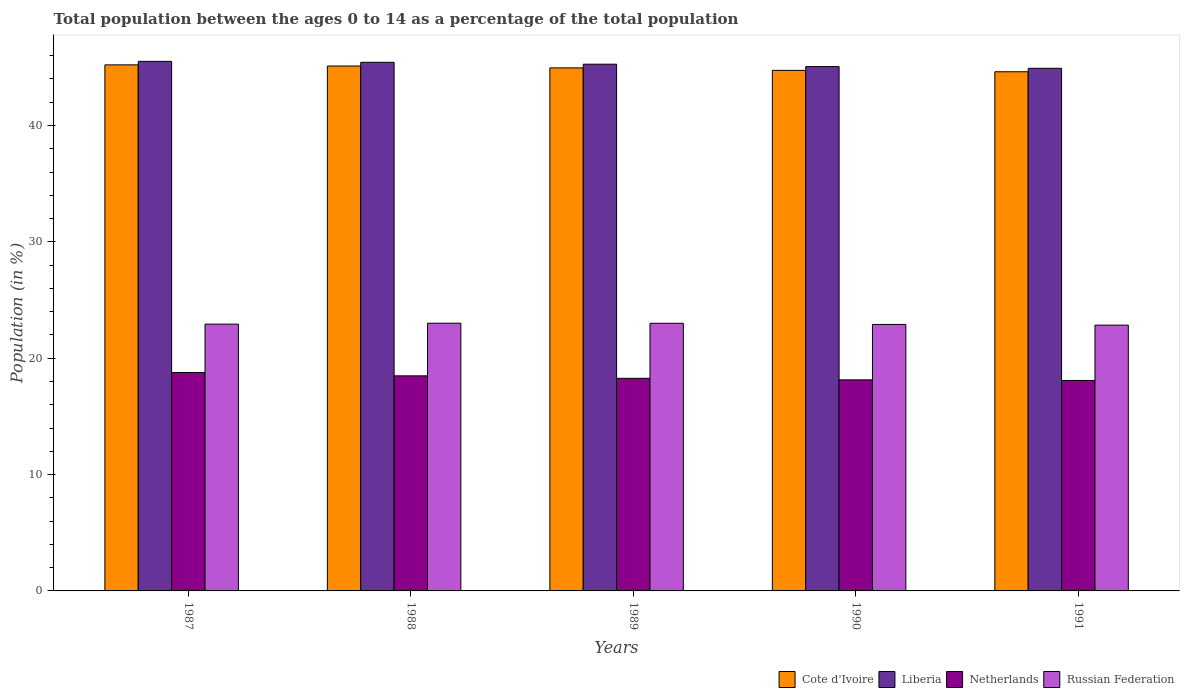How many different coloured bars are there?
Offer a terse response. 4. How many groups of bars are there?
Provide a short and direct response. 5. Are the number of bars per tick equal to the number of legend labels?
Your answer should be very brief. Yes. In how many cases, is the number of bars for a given year not equal to the number of legend labels?
Make the answer very short. 0. What is the percentage of the population ages 0 to 14 in Netherlands in 1988?
Offer a terse response. 18.48. Across all years, what is the maximum percentage of the population ages 0 to 14 in Netherlands?
Keep it short and to the point. 18.77. Across all years, what is the minimum percentage of the population ages 0 to 14 in Liberia?
Your answer should be compact. 44.92. What is the total percentage of the population ages 0 to 14 in Russian Federation in the graph?
Your response must be concise. 114.68. What is the difference between the percentage of the population ages 0 to 14 in Liberia in 1989 and that in 1990?
Ensure brevity in your answer.  0.21. What is the difference between the percentage of the population ages 0 to 14 in Russian Federation in 1991 and the percentage of the population ages 0 to 14 in Netherlands in 1990?
Your answer should be compact. 4.7. What is the average percentage of the population ages 0 to 14 in Liberia per year?
Keep it short and to the point. 45.24. In the year 1988, what is the difference between the percentage of the population ages 0 to 14 in Netherlands and percentage of the population ages 0 to 14 in Liberia?
Ensure brevity in your answer.  -26.95. What is the ratio of the percentage of the population ages 0 to 14 in Liberia in 1989 to that in 1991?
Provide a short and direct response. 1.01. Is the percentage of the population ages 0 to 14 in Netherlands in 1987 less than that in 1989?
Your answer should be compact. No. What is the difference between the highest and the second highest percentage of the population ages 0 to 14 in Cote d'Ivoire?
Your answer should be compact. 0.1. What is the difference between the highest and the lowest percentage of the population ages 0 to 14 in Russian Federation?
Keep it short and to the point. 0.17. In how many years, is the percentage of the population ages 0 to 14 in Cote d'Ivoire greater than the average percentage of the population ages 0 to 14 in Cote d'Ivoire taken over all years?
Your answer should be very brief. 3. What does the 2nd bar from the left in 1991 represents?
Ensure brevity in your answer.  Liberia. What does the 2nd bar from the right in 1991 represents?
Give a very brief answer. Netherlands. How many bars are there?
Your response must be concise. 20. How many years are there in the graph?
Provide a short and direct response. 5. Are the values on the major ticks of Y-axis written in scientific E-notation?
Keep it short and to the point. No. Does the graph contain grids?
Offer a terse response. No. Where does the legend appear in the graph?
Your response must be concise. Bottom right. How many legend labels are there?
Ensure brevity in your answer.  4. What is the title of the graph?
Keep it short and to the point. Total population between the ages 0 to 14 as a percentage of the total population. What is the label or title of the X-axis?
Make the answer very short. Years. What is the label or title of the Y-axis?
Your response must be concise. Population (in %). What is the Population (in %) of Cote d'Ivoire in 1987?
Ensure brevity in your answer.  45.21. What is the Population (in %) in Liberia in 1987?
Your answer should be very brief. 45.51. What is the Population (in %) of Netherlands in 1987?
Provide a short and direct response. 18.77. What is the Population (in %) in Russian Federation in 1987?
Keep it short and to the point. 22.93. What is the Population (in %) in Cote d'Ivoire in 1988?
Your response must be concise. 45.11. What is the Population (in %) of Liberia in 1988?
Ensure brevity in your answer.  45.43. What is the Population (in %) in Netherlands in 1988?
Your answer should be compact. 18.48. What is the Population (in %) in Russian Federation in 1988?
Offer a terse response. 23.01. What is the Population (in %) of Cote d'Ivoire in 1989?
Your answer should be compact. 44.95. What is the Population (in %) of Liberia in 1989?
Your answer should be compact. 45.27. What is the Population (in %) in Netherlands in 1989?
Provide a succinct answer. 18.27. What is the Population (in %) of Russian Federation in 1989?
Keep it short and to the point. 23. What is the Population (in %) in Cote d'Ivoire in 1990?
Keep it short and to the point. 44.74. What is the Population (in %) in Liberia in 1990?
Give a very brief answer. 45.06. What is the Population (in %) of Netherlands in 1990?
Your answer should be compact. 18.14. What is the Population (in %) in Russian Federation in 1990?
Provide a succinct answer. 22.9. What is the Population (in %) of Cote d'Ivoire in 1991?
Your answer should be compact. 44.62. What is the Population (in %) in Liberia in 1991?
Your answer should be very brief. 44.92. What is the Population (in %) in Netherlands in 1991?
Your answer should be very brief. 18.09. What is the Population (in %) of Russian Federation in 1991?
Provide a short and direct response. 22.84. Across all years, what is the maximum Population (in %) in Cote d'Ivoire?
Provide a short and direct response. 45.21. Across all years, what is the maximum Population (in %) in Liberia?
Provide a succinct answer. 45.51. Across all years, what is the maximum Population (in %) in Netherlands?
Your answer should be compact. 18.77. Across all years, what is the maximum Population (in %) of Russian Federation?
Your answer should be compact. 23.01. Across all years, what is the minimum Population (in %) in Cote d'Ivoire?
Keep it short and to the point. 44.62. Across all years, what is the minimum Population (in %) of Liberia?
Your answer should be compact. 44.92. Across all years, what is the minimum Population (in %) of Netherlands?
Your answer should be compact. 18.09. Across all years, what is the minimum Population (in %) of Russian Federation?
Provide a short and direct response. 22.84. What is the total Population (in %) of Cote d'Ivoire in the graph?
Keep it short and to the point. 224.62. What is the total Population (in %) of Liberia in the graph?
Ensure brevity in your answer.  226.18. What is the total Population (in %) of Netherlands in the graph?
Provide a short and direct response. 91.75. What is the total Population (in %) in Russian Federation in the graph?
Your answer should be compact. 114.68. What is the difference between the Population (in %) of Cote d'Ivoire in 1987 and that in 1988?
Provide a short and direct response. 0.1. What is the difference between the Population (in %) in Liberia in 1987 and that in 1988?
Provide a short and direct response. 0.08. What is the difference between the Population (in %) in Netherlands in 1987 and that in 1988?
Make the answer very short. 0.28. What is the difference between the Population (in %) in Russian Federation in 1987 and that in 1988?
Provide a short and direct response. -0.08. What is the difference between the Population (in %) of Cote d'Ivoire in 1987 and that in 1989?
Your answer should be very brief. 0.26. What is the difference between the Population (in %) of Liberia in 1987 and that in 1989?
Provide a succinct answer. 0.24. What is the difference between the Population (in %) in Netherlands in 1987 and that in 1989?
Offer a terse response. 0.5. What is the difference between the Population (in %) in Russian Federation in 1987 and that in 1989?
Your answer should be very brief. -0.07. What is the difference between the Population (in %) of Cote d'Ivoire in 1987 and that in 1990?
Make the answer very short. 0.47. What is the difference between the Population (in %) of Liberia in 1987 and that in 1990?
Your response must be concise. 0.45. What is the difference between the Population (in %) in Netherlands in 1987 and that in 1990?
Provide a short and direct response. 0.63. What is the difference between the Population (in %) of Russian Federation in 1987 and that in 1990?
Give a very brief answer. 0.03. What is the difference between the Population (in %) of Cote d'Ivoire in 1987 and that in 1991?
Provide a succinct answer. 0.59. What is the difference between the Population (in %) of Liberia in 1987 and that in 1991?
Give a very brief answer. 0.6. What is the difference between the Population (in %) of Netherlands in 1987 and that in 1991?
Offer a very short reply. 0.68. What is the difference between the Population (in %) of Russian Federation in 1987 and that in 1991?
Your answer should be very brief. 0.09. What is the difference between the Population (in %) in Cote d'Ivoire in 1988 and that in 1989?
Your response must be concise. 0.16. What is the difference between the Population (in %) of Liberia in 1988 and that in 1989?
Your response must be concise. 0.16. What is the difference between the Population (in %) in Netherlands in 1988 and that in 1989?
Provide a short and direct response. 0.21. What is the difference between the Population (in %) in Russian Federation in 1988 and that in 1989?
Ensure brevity in your answer.  0.01. What is the difference between the Population (in %) of Liberia in 1988 and that in 1990?
Offer a very short reply. 0.37. What is the difference between the Population (in %) of Netherlands in 1988 and that in 1990?
Your answer should be very brief. 0.34. What is the difference between the Population (in %) of Russian Federation in 1988 and that in 1990?
Offer a terse response. 0.1. What is the difference between the Population (in %) in Cote d'Ivoire in 1988 and that in 1991?
Give a very brief answer. 0.49. What is the difference between the Population (in %) in Liberia in 1988 and that in 1991?
Offer a terse response. 0.51. What is the difference between the Population (in %) in Netherlands in 1988 and that in 1991?
Ensure brevity in your answer.  0.39. What is the difference between the Population (in %) in Russian Federation in 1988 and that in 1991?
Your answer should be compact. 0.17. What is the difference between the Population (in %) in Cote d'Ivoire in 1989 and that in 1990?
Your answer should be very brief. 0.22. What is the difference between the Population (in %) of Liberia in 1989 and that in 1990?
Make the answer very short. 0.21. What is the difference between the Population (in %) of Netherlands in 1989 and that in 1990?
Provide a succinct answer. 0.13. What is the difference between the Population (in %) of Russian Federation in 1989 and that in 1990?
Make the answer very short. 0.1. What is the difference between the Population (in %) in Liberia in 1989 and that in 1991?
Offer a very short reply. 0.35. What is the difference between the Population (in %) in Netherlands in 1989 and that in 1991?
Give a very brief answer. 0.18. What is the difference between the Population (in %) of Russian Federation in 1989 and that in 1991?
Offer a terse response. 0.16. What is the difference between the Population (in %) of Cote d'Ivoire in 1990 and that in 1991?
Offer a very short reply. 0.12. What is the difference between the Population (in %) of Liberia in 1990 and that in 1991?
Make the answer very short. 0.15. What is the difference between the Population (in %) of Netherlands in 1990 and that in 1991?
Your answer should be very brief. 0.05. What is the difference between the Population (in %) in Russian Federation in 1990 and that in 1991?
Offer a very short reply. 0.06. What is the difference between the Population (in %) in Cote d'Ivoire in 1987 and the Population (in %) in Liberia in 1988?
Make the answer very short. -0.22. What is the difference between the Population (in %) of Cote d'Ivoire in 1987 and the Population (in %) of Netherlands in 1988?
Your response must be concise. 26.73. What is the difference between the Population (in %) in Cote d'Ivoire in 1987 and the Population (in %) in Russian Federation in 1988?
Offer a terse response. 22.2. What is the difference between the Population (in %) in Liberia in 1987 and the Population (in %) in Netherlands in 1988?
Your response must be concise. 27.03. What is the difference between the Population (in %) of Liberia in 1987 and the Population (in %) of Russian Federation in 1988?
Offer a terse response. 22.5. What is the difference between the Population (in %) of Netherlands in 1987 and the Population (in %) of Russian Federation in 1988?
Your answer should be very brief. -4.24. What is the difference between the Population (in %) of Cote d'Ivoire in 1987 and the Population (in %) of Liberia in 1989?
Your response must be concise. -0.06. What is the difference between the Population (in %) in Cote d'Ivoire in 1987 and the Population (in %) in Netherlands in 1989?
Give a very brief answer. 26.94. What is the difference between the Population (in %) in Cote d'Ivoire in 1987 and the Population (in %) in Russian Federation in 1989?
Offer a terse response. 22.21. What is the difference between the Population (in %) in Liberia in 1987 and the Population (in %) in Netherlands in 1989?
Offer a terse response. 27.24. What is the difference between the Population (in %) of Liberia in 1987 and the Population (in %) of Russian Federation in 1989?
Give a very brief answer. 22.51. What is the difference between the Population (in %) in Netherlands in 1987 and the Population (in %) in Russian Federation in 1989?
Your response must be concise. -4.23. What is the difference between the Population (in %) in Cote d'Ivoire in 1987 and the Population (in %) in Liberia in 1990?
Provide a short and direct response. 0.15. What is the difference between the Population (in %) of Cote d'Ivoire in 1987 and the Population (in %) of Netherlands in 1990?
Provide a short and direct response. 27.07. What is the difference between the Population (in %) of Cote d'Ivoire in 1987 and the Population (in %) of Russian Federation in 1990?
Provide a short and direct response. 22.31. What is the difference between the Population (in %) in Liberia in 1987 and the Population (in %) in Netherlands in 1990?
Offer a terse response. 27.37. What is the difference between the Population (in %) of Liberia in 1987 and the Population (in %) of Russian Federation in 1990?
Ensure brevity in your answer.  22.61. What is the difference between the Population (in %) in Netherlands in 1987 and the Population (in %) in Russian Federation in 1990?
Give a very brief answer. -4.14. What is the difference between the Population (in %) in Cote d'Ivoire in 1987 and the Population (in %) in Liberia in 1991?
Your answer should be very brief. 0.29. What is the difference between the Population (in %) of Cote d'Ivoire in 1987 and the Population (in %) of Netherlands in 1991?
Your answer should be very brief. 27.12. What is the difference between the Population (in %) of Cote d'Ivoire in 1987 and the Population (in %) of Russian Federation in 1991?
Your answer should be compact. 22.37. What is the difference between the Population (in %) of Liberia in 1987 and the Population (in %) of Netherlands in 1991?
Give a very brief answer. 27.42. What is the difference between the Population (in %) in Liberia in 1987 and the Population (in %) in Russian Federation in 1991?
Provide a succinct answer. 22.67. What is the difference between the Population (in %) in Netherlands in 1987 and the Population (in %) in Russian Federation in 1991?
Give a very brief answer. -4.07. What is the difference between the Population (in %) in Cote d'Ivoire in 1988 and the Population (in %) in Liberia in 1989?
Keep it short and to the point. -0.16. What is the difference between the Population (in %) in Cote d'Ivoire in 1988 and the Population (in %) in Netherlands in 1989?
Offer a terse response. 26.84. What is the difference between the Population (in %) in Cote d'Ivoire in 1988 and the Population (in %) in Russian Federation in 1989?
Provide a short and direct response. 22.11. What is the difference between the Population (in %) of Liberia in 1988 and the Population (in %) of Netherlands in 1989?
Give a very brief answer. 27.16. What is the difference between the Population (in %) in Liberia in 1988 and the Population (in %) in Russian Federation in 1989?
Offer a very short reply. 22.43. What is the difference between the Population (in %) of Netherlands in 1988 and the Population (in %) of Russian Federation in 1989?
Offer a very short reply. -4.52. What is the difference between the Population (in %) in Cote d'Ivoire in 1988 and the Population (in %) in Liberia in 1990?
Keep it short and to the point. 0.05. What is the difference between the Population (in %) of Cote d'Ivoire in 1988 and the Population (in %) of Netherlands in 1990?
Your answer should be very brief. 26.97. What is the difference between the Population (in %) in Cote d'Ivoire in 1988 and the Population (in %) in Russian Federation in 1990?
Offer a terse response. 22.21. What is the difference between the Population (in %) of Liberia in 1988 and the Population (in %) of Netherlands in 1990?
Ensure brevity in your answer.  27.29. What is the difference between the Population (in %) of Liberia in 1988 and the Population (in %) of Russian Federation in 1990?
Offer a terse response. 22.53. What is the difference between the Population (in %) of Netherlands in 1988 and the Population (in %) of Russian Federation in 1990?
Make the answer very short. -4.42. What is the difference between the Population (in %) in Cote d'Ivoire in 1988 and the Population (in %) in Liberia in 1991?
Your answer should be compact. 0.2. What is the difference between the Population (in %) in Cote d'Ivoire in 1988 and the Population (in %) in Netherlands in 1991?
Keep it short and to the point. 27.02. What is the difference between the Population (in %) of Cote d'Ivoire in 1988 and the Population (in %) of Russian Federation in 1991?
Your answer should be very brief. 22.27. What is the difference between the Population (in %) of Liberia in 1988 and the Population (in %) of Netherlands in 1991?
Ensure brevity in your answer.  27.34. What is the difference between the Population (in %) of Liberia in 1988 and the Population (in %) of Russian Federation in 1991?
Your answer should be very brief. 22.59. What is the difference between the Population (in %) in Netherlands in 1988 and the Population (in %) in Russian Federation in 1991?
Your answer should be very brief. -4.36. What is the difference between the Population (in %) in Cote d'Ivoire in 1989 and the Population (in %) in Liberia in 1990?
Your response must be concise. -0.11. What is the difference between the Population (in %) in Cote d'Ivoire in 1989 and the Population (in %) in Netherlands in 1990?
Provide a short and direct response. 26.81. What is the difference between the Population (in %) in Cote d'Ivoire in 1989 and the Population (in %) in Russian Federation in 1990?
Your answer should be compact. 22.05. What is the difference between the Population (in %) in Liberia in 1989 and the Population (in %) in Netherlands in 1990?
Keep it short and to the point. 27.13. What is the difference between the Population (in %) of Liberia in 1989 and the Population (in %) of Russian Federation in 1990?
Offer a terse response. 22.36. What is the difference between the Population (in %) of Netherlands in 1989 and the Population (in %) of Russian Federation in 1990?
Give a very brief answer. -4.63. What is the difference between the Population (in %) in Cote d'Ivoire in 1989 and the Population (in %) in Liberia in 1991?
Provide a short and direct response. 0.04. What is the difference between the Population (in %) in Cote d'Ivoire in 1989 and the Population (in %) in Netherlands in 1991?
Your answer should be very brief. 26.86. What is the difference between the Population (in %) of Cote d'Ivoire in 1989 and the Population (in %) of Russian Federation in 1991?
Provide a succinct answer. 22.11. What is the difference between the Population (in %) in Liberia in 1989 and the Population (in %) in Netherlands in 1991?
Offer a terse response. 27.18. What is the difference between the Population (in %) in Liberia in 1989 and the Population (in %) in Russian Federation in 1991?
Your answer should be compact. 22.42. What is the difference between the Population (in %) in Netherlands in 1989 and the Population (in %) in Russian Federation in 1991?
Your response must be concise. -4.57. What is the difference between the Population (in %) of Cote d'Ivoire in 1990 and the Population (in %) of Liberia in 1991?
Your answer should be compact. -0.18. What is the difference between the Population (in %) in Cote d'Ivoire in 1990 and the Population (in %) in Netherlands in 1991?
Provide a short and direct response. 26.65. What is the difference between the Population (in %) in Cote d'Ivoire in 1990 and the Population (in %) in Russian Federation in 1991?
Give a very brief answer. 21.89. What is the difference between the Population (in %) in Liberia in 1990 and the Population (in %) in Netherlands in 1991?
Keep it short and to the point. 26.97. What is the difference between the Population (in %) of Liberia in 1990 and the Population (in %) of Russian Federation in 1991?
Your answer should be very brief. 22.22. What is the difference between the Population (in %) in Netherlands in 1990 and the Population (in %) in Russian Federation in 1991?
Offer a terse response. -4.7. What is the average Population (in %) of Cote d'Ivoire per year?
Make the answer very short. 44.92. What is the average Population (in %) of Liberia per year?
Make the answer very short. 45.24. What is the average Population (in %) of Netherlands per year?
Your answer should be compact. 18.35. What is the average Population (in %) of Russian Federation per year?
Keep it short and to the point. 22.94. In the year 1987, what is the difference between the Population (in %) in Cote d'Ivoire and Population (in %) in Liberia?
Make the answer very short. -0.3. In the year 1987, what is the difference between the Population (in %) of Cote d'Ivoire and Population (in %) of Netherlands?
Your response must be concise. 26.44. In the year 1987, what is the difference between the Population (in %) in Cote d'Ivoire and Population (in %) in Russian Federation?
Your answer should be very brief. 22.28. In the year 1987, what is the difference between the Population (in %) in Liberia and Population (in %) in Netherlands?
Your answer should be compact. 26.74. In the year 1987, what is the difference between the Population (in %) of Liberia and Population (in %) of Russian Federation?
Your answer should be compact. 22.58. In the year 1987, what is the difference between the Population (in %) in Netherlands and Population (in %) in Russian Federation?
Your answer should be very brief. -4.16. In the year 1988, what is the difference between the Population (in %) of Cote d'Ivoire and Population (in %) of Liberia?
Provide a succinct answer. -0.32. In the year 1988, what is the difference between the Population (in %) in Cote d'Ivoire and Population (in %) in Netherlands?
Make the answer very short. 26.63. In the year 1988, what is the difference between the Population (in %) in Cote d'Ivoire and Population (in %) in Russian Federation?
Your response must be concise. 22.1. In the year 1988, what is the difference between the Population (in %) of Liberia and Population (in %) of Netherlands?
Give a very brief answer. 26.95. In the year 1988, what is the difference between the Population (in %) of Liberia and Population (in %) of Russian Federation?
Offer a very short reply. 22.42. In the year 1988, what is the difference between the Population (in %) in Netherlands and Population (in %) in Russian Federation?
Your response must be concise. -4.52. In the year 1989, what is the difference between the Population (in %) of Cote d'Ivoire and Population (in %) of Liberia?
Your answer should be very brief. -0.32. In the year 1989, what is the difference between the Population (in %) in Cote d'Ivoire and Population (in %) in Netherlands?
Offer a very short reply. 26.68. In the year 1989, what is the difference between the Population (in %) in Cote d'Ivoire and Population (in %) in Russian Federation?
Your response must be concise. 21.95. In the year 1989, what is the difference between the Population (in %) of Liberia and Population (in %) of Netherlands?
Provide a short and direct response. 27. In the year 1989, what is the difference between the Population (in %) of Liberia and Population (in %) of Russian Federation?
Your answer should be very brief. 22.26. In the year 1989, what is the difference between the Population (in %) of Netherlands and Population (in %) of Russian Federation?
Provide a short and direct response. -4.73. In the year 1990, what is the difference between the Population (in %) in Cote d'Ivoire and Population (in %) in Liberia?
Your answer should be very brief. -0.33. In the year 1990, what is the difference between the Population (in %) in Cote d'Ivoire and Population (in %) in Netherlands?
Ensure brevity in your answer.  26.6. In the year 1990, what is the difference between the Population (in %) in Cote d'Ivoire and Population (in %) in Russian Federation?
Offer a very short reply. 21.83. In the year 1990, what is the difference between the Population (in %) of Liberia and Population (in %) of Netherlands?
Provide a succinct answer. 26.92. In the year 1990, what is the difference between the Population (in %) of Liberia and Population (in %) of Russian Federation?
Ensure brevity in your answer.  22.16. In the year 1990, what is the difference between the Population (in %) in Netherlands and Population (in %) in Russian Federation?
Your response must be concise. -4.76. In the year 1991, what is the difference between the Population (in %) of Cote d'Ivoire and Population (in %) of Liberia?
Provide a succinct answer. -0.3. In the year 1991, what is the difference between the Population (in %) of Cote d'Ivoire and Population (in %) of Netherlands?
Provide a short and direct response. 26.53. In the year 1991, what is the difference between the Population (in %) in Cote d'Ivoire and Population (in %) in Russian Federation?
Give a very brief answer. 21.78. In the year 1991, what is the difference between the Population (in %) of Liberia and Population (in %) of Netherlands?
Offer a very short reply. 26.83. In the year 1991, what is the difference between the Population (in %) of Liberia and Population (in %) of Russian Federation?
Your response must be concise. 22.07. In the year 1991, what is the difference between the Population (in %) in Netherlands and Population (in %) in Russian Federation?
Your response must be concise. -4.75. What is the ratio of the Population (in %) in Cote d'Ivoire in 1987 to that in 1988?
Ensure brevity in your answer.  1. What is the ratio of the Population (in %) of Netherlands in 1987 to that in 1988?
Offer a terse response. 1.02. What is the ratio of the Population (in %) of Russian Federation in 1987 to that in 1988?
Make the answer very short. 1. What is the ratio of the Population (in %) in Liberia in 1987 to that in 1989?
Make the answer very short. 1.01. What is the ratio of the Population (in %) in Netherlands in 1987 to that in 1989?
Make the answer very short. 1.03. What is the ratio of the Population (in %) of Russian Federation in 1987 to that in 1989?
Give a very brief answer. 1. What is the ratio of the Population (in %) in Cote d'Ivoire in 1987 to that in 1990?
Your response must be concise. 1.01. What is the ratio of the Population (in %) in Netherlands in 1987 to that in 1990?
Make the answer very short. 1.03. What is the ratio of the Population (in %) in Russian Federation in 1987 to that in 1990?
Your response must be concise. 1. What is the ratio of the Population (in %) of Cote d'Ivoire in 1987 to that in 1991?
Make the answer very short. 1.01. What is the ratio of the Population (in %) of Liberia in 1987 to that in 1991?
Your response must be concise. 1.01. What is the ratio of the Population (in %) in Netherlands in 1987 to that in 1991?
Ensure brevity in your answer.  1.04. What is the ratio of the Population (in %) in Cote d'Ivoire in 1988 to that in 1989?
Keep it short and to the point. 1. What is the ratio of the Population (in %) of Liberia in 1988 to that in 1989?
Your response must be concise. 1. What is the ratio of the Population (in %) in Netherlands in 1988 to that in 1989?
Offer a terse response. 1.01. What is the ratio of the Population (in %) of Cote d'Ivoire in 1988 to that in 1990?
Offer a terse response. 1.01. What is the ratio of the Population (in %) in Liberia in 1988 to that in 1990?
Make the answer very short. 1.01. What is the ratio of the Population (in %) in Netherlands in 1988 to that in 1990?
Your answer should be very brief. 1.02. What is the ratio of the Population (in %) of Cote d'Ivoire in 1988 to that in 1991?
Give a very brief answer. 1.01. What is the ratio of the Population (in %) in Liberia in 1988 to that in 1991?
Provide a succinct answer. 1.01. What is the ratio of the Population (in %) in Netherlands in 1988 to that in 1991?
Make the answer very short. 1.02. What is the ratio of the Population (in %) of Russian Federation in 1988 to that in 1991?
Your response must be concise. 1.01. What is the ratio of the Population (in %) in Liberia in 1989 to that in 1990?
Your response must be concise. 1. What is the ratio of the Population (in %) in Netherlands in 1989 to that in 1990?
Your answer should be very brief. 1.01. What is the ratio of the Population (in %) in Cote d'Ivoire in 1989 to that in 1991?
Keep it short and to the point. 1.01. What is the ratio of the Population (in %) in Liberia in 1989 to that in 1991?
Make the answer very short. 1.01. What is the ratio of the Population (in %) of Netherlands in 1989 to that in 1991?
Make the answer very short. 1.01. What is the ratio of the Population (in %) of Cote d'Ivoire in 1990 to that in 1991?
Provide a short and direct response. 1. What is the ratio of the Population (in %) of Russian Federation in 1990 to that in 1991?
Offer a terse response. 1. What is the difference between the highest and the second highest Population (in %) in Cote d'Ivoire?
Offer a very short reply. 0.1. What is the difference between the highest and the second highest Population (in %) of Liberia?
Ensure brevity in your answer.  0.08. What is the difference between the highest and the second highest Population (in %) in Netherlands?
Provide a short and direct response. 0.28. What is the difference between the highest and the second highest Population (in %) in Russian Federation?
Offer a terse response. 0.01. What is the difference between the highest and the lowest Population (in %) of Cote d'Ivoire?
Offer a terse response. 0.59. What is the difference between the highest and the lowest Population (in %) in Liberia?
Ensure brevity in your answer.  0.6. What is the difference between the highest and the lowest Population (in %) of Netherlands?
Provide a short and direct response. 0.68. What is the difference between the highest and the lowest Population (in %) of Russian Federation?
Provide a short and direct response. 0.17. 